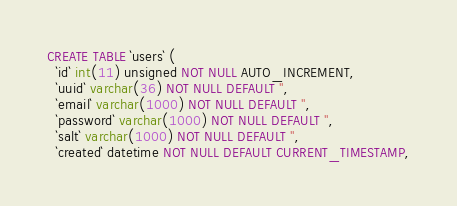Convert code to text. <code><loc_0><loc_0><loc_500><loc_500><_SQL_>CREATE TABLE `users` (
  `id` int(11) unsigned NOT NULL AUTO_INCREMENT,
  `uuid` varchar(36) NOT NULL DEFAULT '',
  `email` varchar(1000) NOT NULL DEFAULT '',
  `password` varchar(1000) NOT NULL DEFAULT '',
  `salt` varchar(1000) NOT NULL DEFAULT '',  
  `created` datetime NOT NULL DEFAULT CURRENT_TIMESTAMP,</code> 